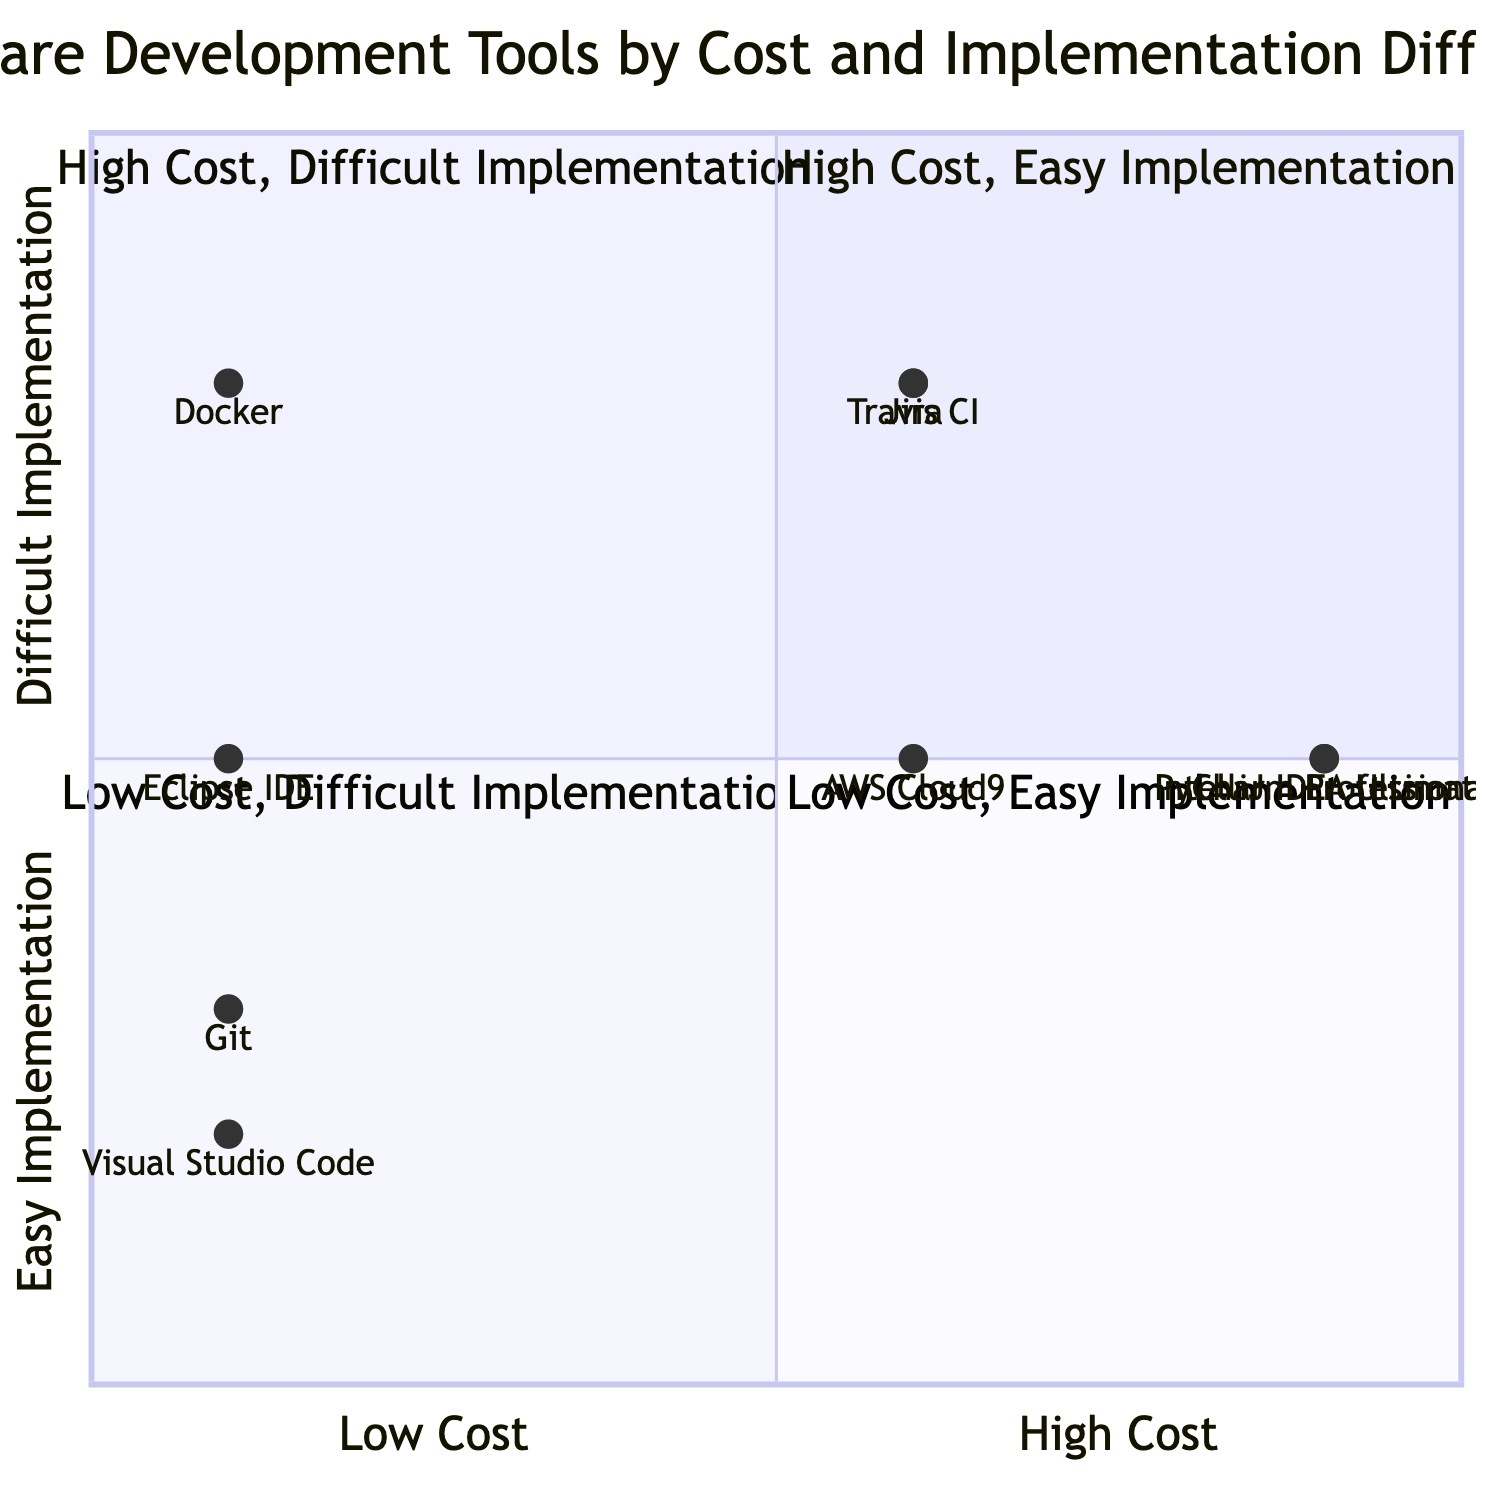What is the cost of Visual Studio Code? The diagram indicates that Visual Studio Code is positioned at a point representing free cost along the x-axis. Therefore, it has a cost value of "Free."
Answer: Free Which tool has the highest implementation difficulty in the third quadrant? In the third quadrant (Low Cost, Difficult Implementation), we observe that Docker is the only tool that meets these criteria. Therefore, it has the highest implementation difficulty in this quadrant.
Answer: Docker How many tools are categorized as Low Cost, Easy Implementation? To find this, we look at the fourth quadrant (Low Cost, Easy Implementation) where there are two tools: Visual Studio Code and Git. The count of these tools is 2.
Answer: 2 What is the implementation difficulty of IntelliJ IDEA Ultimate? The diagram shows that IntelliJ IDEA Ultimate falls into quadrant 2, which symbolizes High Cost and Difficult Implementation, indicating that its implementation difficulty is classified as Medium.
Answer: Medium Which tool costs the same as AWS Cloud9 but has a higher implementation difficulty? Analyzing both cost and implementation difficulty, we see AWS Cloud9 (Medium cost; Medium difficulty) aligns with Jira and Travis CI (both are Medium cost). However, both those tools have a higher implementation difficulty (High). Therefore, the answer is Jira and Travis CI.
Answer: Jira, Travis CI Which tool is in quadrant 1? Quadrant 1 contains High Cost and Easy Implementation items. According to the diagram, the only tool in this quadrant is IntelliJ IDEA Ultimate, thus confirming its position.
Answer: IntelliJ IDEA Ultimate What is the primary difference in cost between Git and PyCharm Professional? Git is placed in the Low Cost category while PyCharm Professional is in the High Cost segment. Therefore, the difference can be determined as "High" for PyCharm Professional and "Free" for Git.
Answer: High Are there any tools that fall under High Cost, Difficult Implementation? By evaluating quadrant 2 (High Cost, Difficult Implementation), we find only Jira and IntelliJ IDEA Ultimate positioned here, confirming there are two tools under this category.
Answer: Yes How does Docker's implementation difficulty compare to Jira? Docker is classified as High implementation difficulty, while Jira is noted as High implementation difficulty in the diagram, making their implementation difficulties equal.
Answer: Equal 